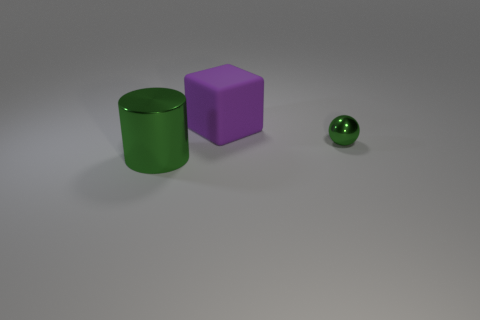Is there a shiny cylinder that has the same color as the tiny metal sphere?
Provide a succinct answer. Yes. Is there any other thing that has the same shape as the purple rubber object?
Offer a terse response. No. Are there an equal number of big green objects behind the green sphere and tiny green balls that are behind the large purple object?
Offer a very short reply. Yes. Is there any other thing that is the same size as the green metal sphere?
Provide a short and direct response. No. There is a thing that is made of the same material as the big green cylinder; what color is it?
Ensure brevity in your answer.  Green. Is the material of the small green ball the same as the green thing that is on the left side of the metallic ball?
Keep it short and to the point. Yes. What is the color of the thing that is both in front of the large matte cube and to the right of the large green thing?
Offer a very short reply. Green. What number of balls are either large things or large matte objects?
Your response must be concise. 0. What size is the thing that is to the left of the small green shiny object and behind the large metal object?
Offer a very short reply. Large. The tiny metallic object is what shape?
Your answer should be very brief. Sphere. 